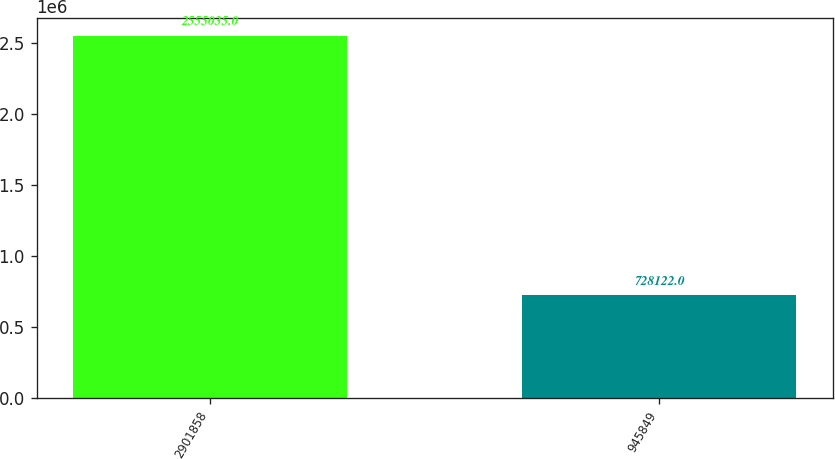Convert chart. <chart><loc_0><loc_0><loc_500><loc_500><bar_chart><fcel>2901858<fcel>945849<nl><fcel>2.55504e+06<fcel>728122<nl></chart> 